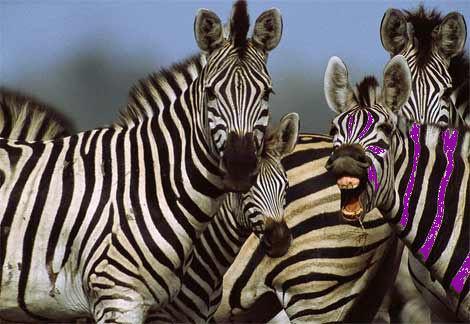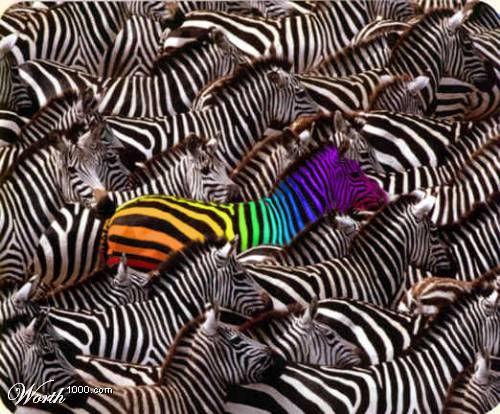The first image is the image on the left, the second image is the image on the right. Given the left and right images, does the statement "In the left image, there is one zebra with black and purple stripes." hold true? Answer yes or no. Yes. The first image is the image on the left, the second image is the image on the right. Assess this claim about the two images: "The left image includes one zebra with only violet tint added, standing on the far right with its body turned leftward.". Correct or not? Answer yes or no. Yes. 